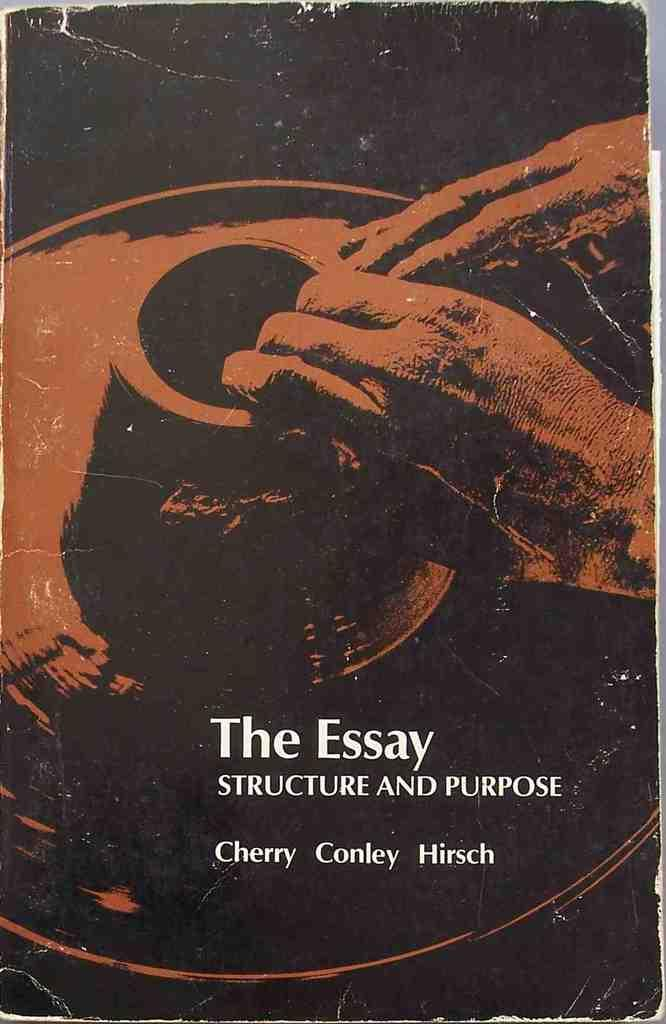<image>
Describe the image concisely. A close up of a book called the The Essay has a picture of a man sculpting clay on a potters wheel on its cover. 